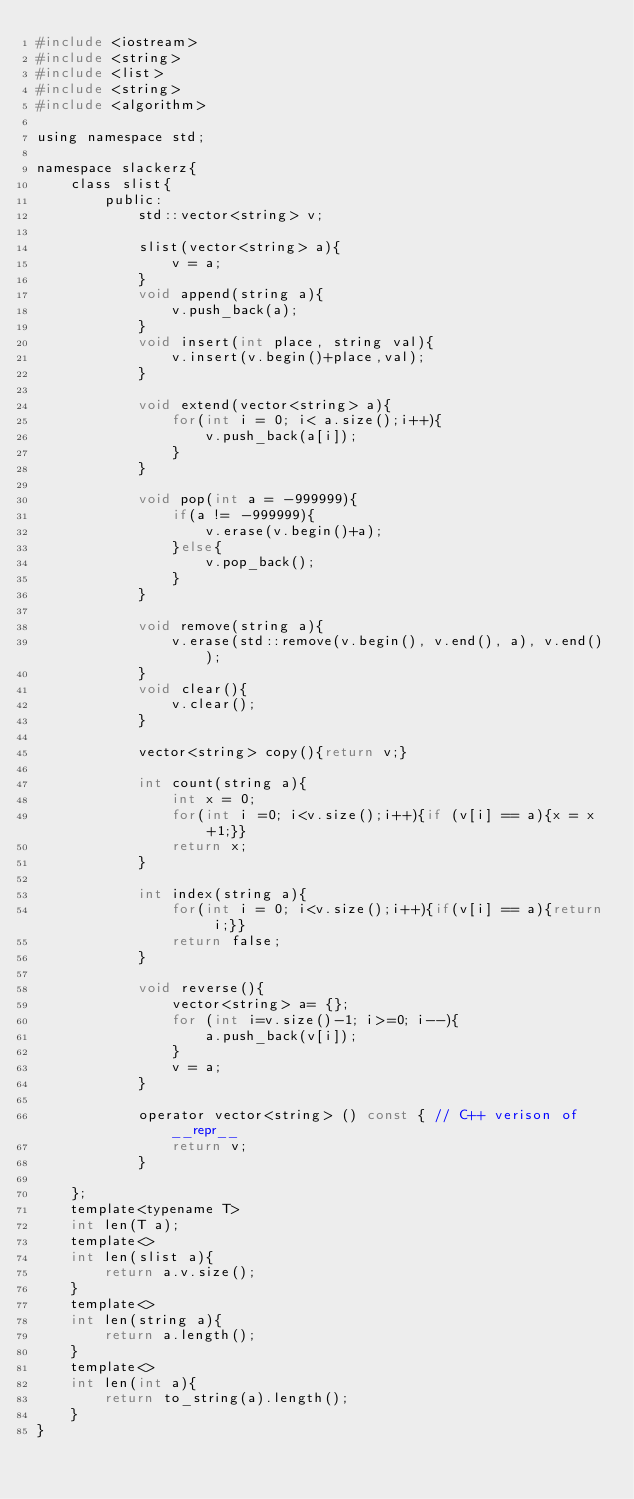<code> <loc_0><loc_0><loc_500><loc_500><_C_>#include <iostream>
#include <string>
#include <list>
#include <string>
#include <algorithm>

using namespace std;

namespace slackerz{
    class slist{
        public:
            std::vector<string> v;

            slist(vector<string> a){
                v = a;
            }
            void append(string a){
                v.push_back(a);
            }
            void insert(int place, string val){
                v.insert(v.begin()+place,val);
            }

            void extend(vector<string> a){
                for(int i = 0; i< a.size();i++){
                    v.push_back(a[i]);
                }
            }

            void pop(int a = -999999){
                if(a != -999999){
                    v.erase(v.begin()+a);
                }else{
                    v.pop_back();
                }
            }

            void remove(string a){
                v.erase(std::remove(v.begin(), v.end(), a), v.end());
            }
            void clear(){
                v.clear();
            }

            vector<string> copy(){return v;}

            int count(string a){
                int x = 0;
                for(int i =0; i<v.size();i++){if (v[i] == a){x = x+1;}}
                return x;
            }

            int index(string a){
                for(int i = 0; i<v.size();i++){if(v[i] == a){return i;}}
                return false;
            }

            void reverse(){
                vector<string> a= {};
                for (int i=v.size()-1; i>=0; i--){
                    a.push_back(v[i]); 
                }
                v = a;
            }

            operator vector<string> () const { // C++ verison of __repr__
            	return v;
        	}
            
    };
    template<typename T>
    int len(T a);
    template<>
    int len(slist a){
        return a.v.size();
    }
    template<>
    int len(string a){
        return a.length();
    }
    template<>
    int len(int a){
        return to_string(a).length();
    }
}</code> 